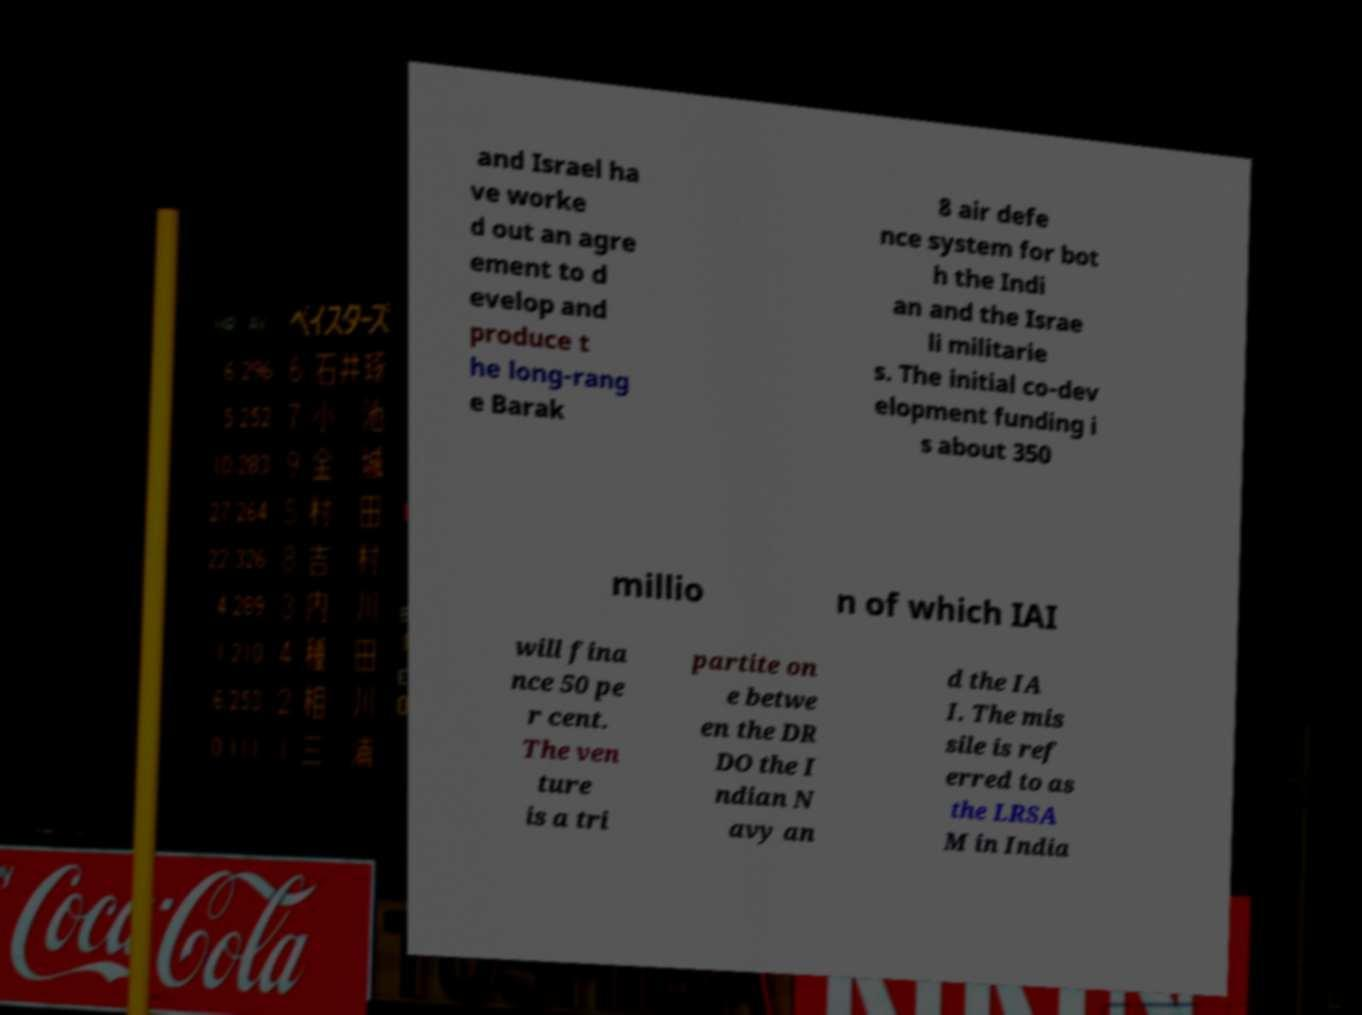Can you read and provide the text displayed in the image?This photo seems to have some interesting text. Can you extract and type it out for me? and Israel ha ve worke d out an agre ement to d evelop and produce t he long-rang e Barak 8 air defe nce system for bot h the Indi an and the Israe li militarie s. The initial co-dev elopment funding i s about 350 millio n of which IAI will fina nce 50 pe r cent. The ven ture is a tri partite on e betwe en the DR DO the I ndian N avy an d the IA I. The mis sile is ref erred to as the LRSA M in India 